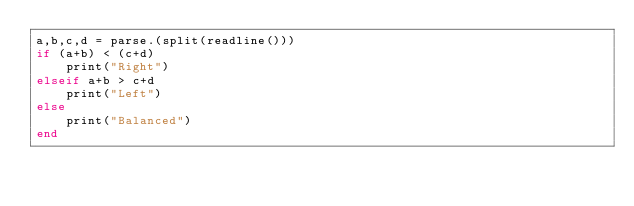Convert code to text. <code><loc_0><loc_0><loc_500><loc_500><_Julia_>a,b,c,d = parse.(split(readline()))
if (a+b) < (c+d)
  	print("Right")
elseif a+b > c+d
  	print("Left")
else
  	print("Balanced")
end</code> 